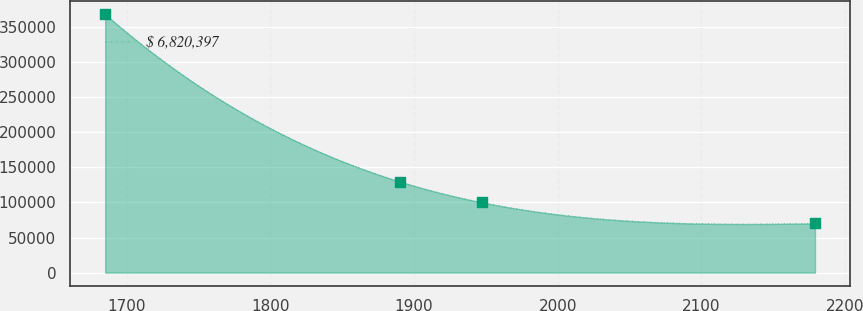Convert chart to OTSL. <chart><loc_0><loc_0><loc_500><loc_500><line_chart><ecel><fcel>$ 6,820,397<nl><fcel>1685.05<fcel>368376<nl><fcel>1889.92<fcel>129871<nl><fcel>1947.34<fcel>100058<nl><fcel>2179.01<fcel>70244.8<nl></chart> 